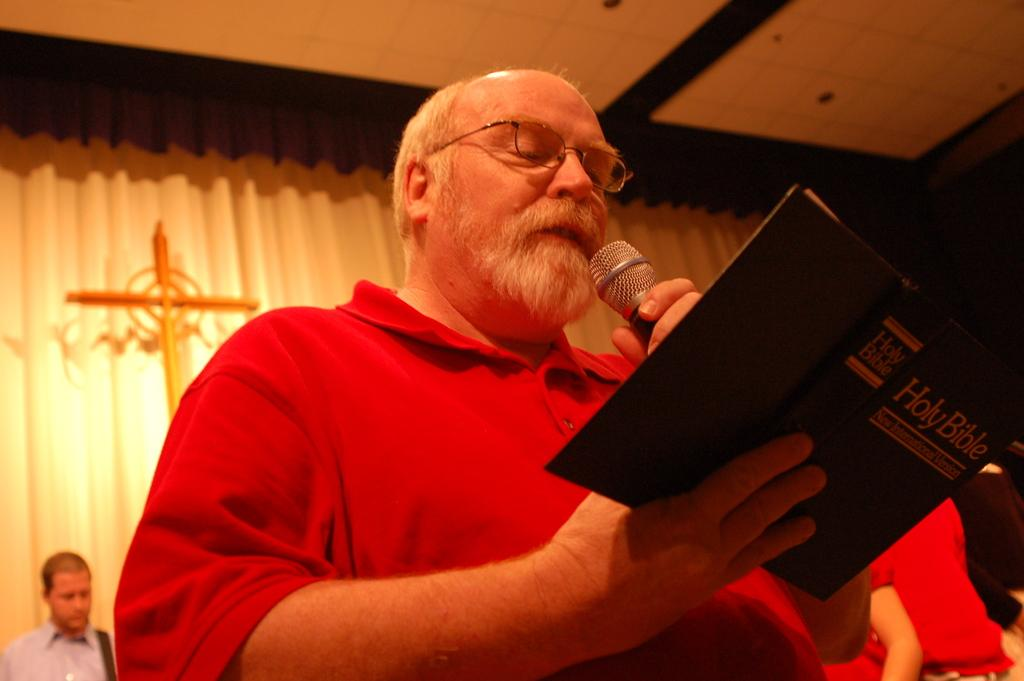How many people are in the image? There are multiple persons in the image. What are two different objects being held by the persons in the image? One person is holding a book, and another person is holding a microphone. What can be seen in the background of the image? There are curtains and a cross symbol in the background of the image. Can you see any bubbles floating around the persons in the image? There are no bubbles present in the image. Are the persons in the image walking through quicksand? There is no indication of quicksand in the image; the persons are standing or holding objects. 